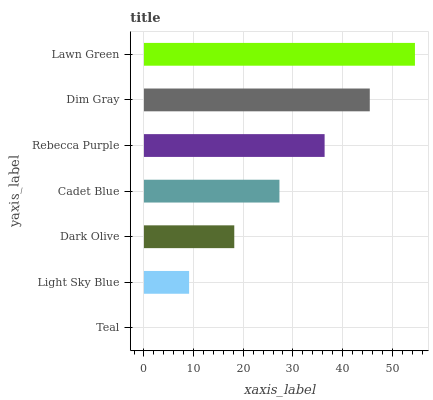Is Teal the minimum?
Answer yes or no. Yes. Is Lawn Green the maximum?
Answer yes or no. Yes. Is Light Sky Blue the minimum?
Answer yes or no. No. Is Light Sky Blue the maximum?
Answer yes or no. No. Is Light Sky Blue greater than Teal?
Answer yes or no. Yes. Is Teal less than Light Sky Blue?
Answer yes or no. Yes. Is Teal greater than Light Sky Blue?
Answer yes or no. No. Is Light Sky Blue less than Teal?
Answer yes or no. No. Is Cadet Blue the high median?
Answer yes or no. Yes. Is Cadet Blue the low median?
Answer yes or no. Yes. Is Light Sky Blue the high median?
Answer yes or no. No. Is Rebecca Purple the low median?
Answer yes or no. No. 